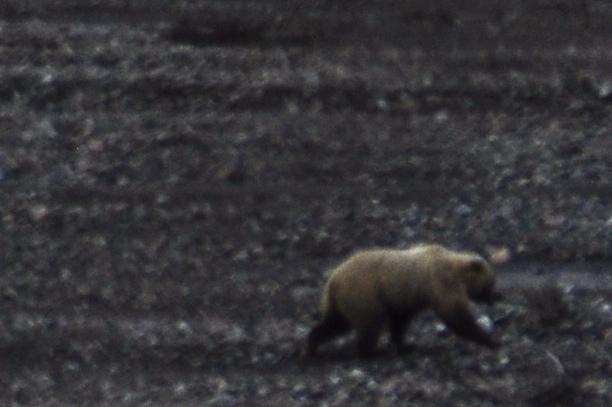How many horses are there?
Give a very brief answer. 0. 